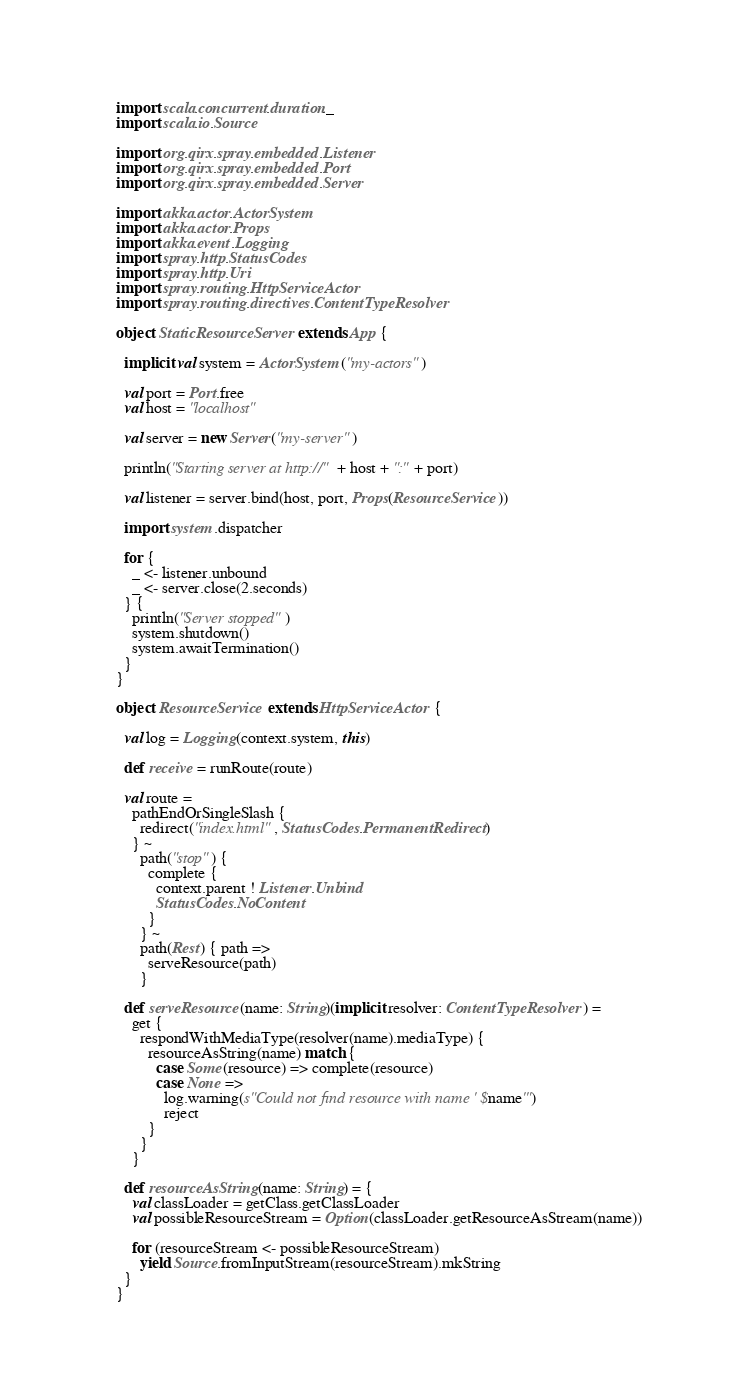<code> <loc_0><loc_0><loc_500><loc_500><_Scala_>
import scala.concurrent.duration._
import scala.io.Source

import org.qirx.spray.embedded.Listener
import org.qirx.spray.embedded.Port
import org.qirx.spray.embedded.Server

import akka.actor.ActorSystem
import akka.actor.Props
import akka.event.Logging
import spray.http.StatusCodes
import spray.http.Uri
import spray.routing.HttpServiceActor
import spray.routing.directives.ContentTypeResolver

object StaticResourceServer extends App {

  implicit val system = ActorSystem("my-actors")

  val port = Port.free
  val host = "localhost"

  val server = new Server("my-server")

  println("Starting server at http://" + host + ":" + port)

  val listener = server.bind(host, port, Props(ResourceService))

  import system.dispatcher

  for {
    _ <- listener.unbound
    _ <- server.close(2.seconds)
  } {
    println("Server stopped")
    system.shutdown()
    system.awaitTermination()
  }
}

object ResourceService extends HttpServiceActor {

  val log = Logging(context.system, this)

  def receive = runRoute(route)

  val route =
    pathEndOrSingleSlash {
      redirect("index.html", StatusCodes.PermanentRedirect)
    } ~
      path("stop") {
        complete {
          context.parent ! Listener.Unbind
          StatusCodes.NoContent
        }
      } ~
      path(Rest) { path =>
        serveResource(path)
      }

  def serveResource(name: String)(implicit resolver: ContentTypeResolver) =
    get {
      respondWithMediaType(resolver(name).mediaType) {
        resourceAsString(name) match {
          case Some(resource) => complete(resource)
          case None =>
            log.warning(s"Could not find resource with name '$name'")
            reject
        }
      }
    }

  def resourceAsString(name: String) = {
    val classLoader = getClass.getClassLoader
    val possibleResourceStream = Option(classLoader.getResourceAsStream(name))

    for (resourceStream <- possibleResourceStream)
      yield Source.fromInputStream(resourceStream).mkString
  }
}</code> 